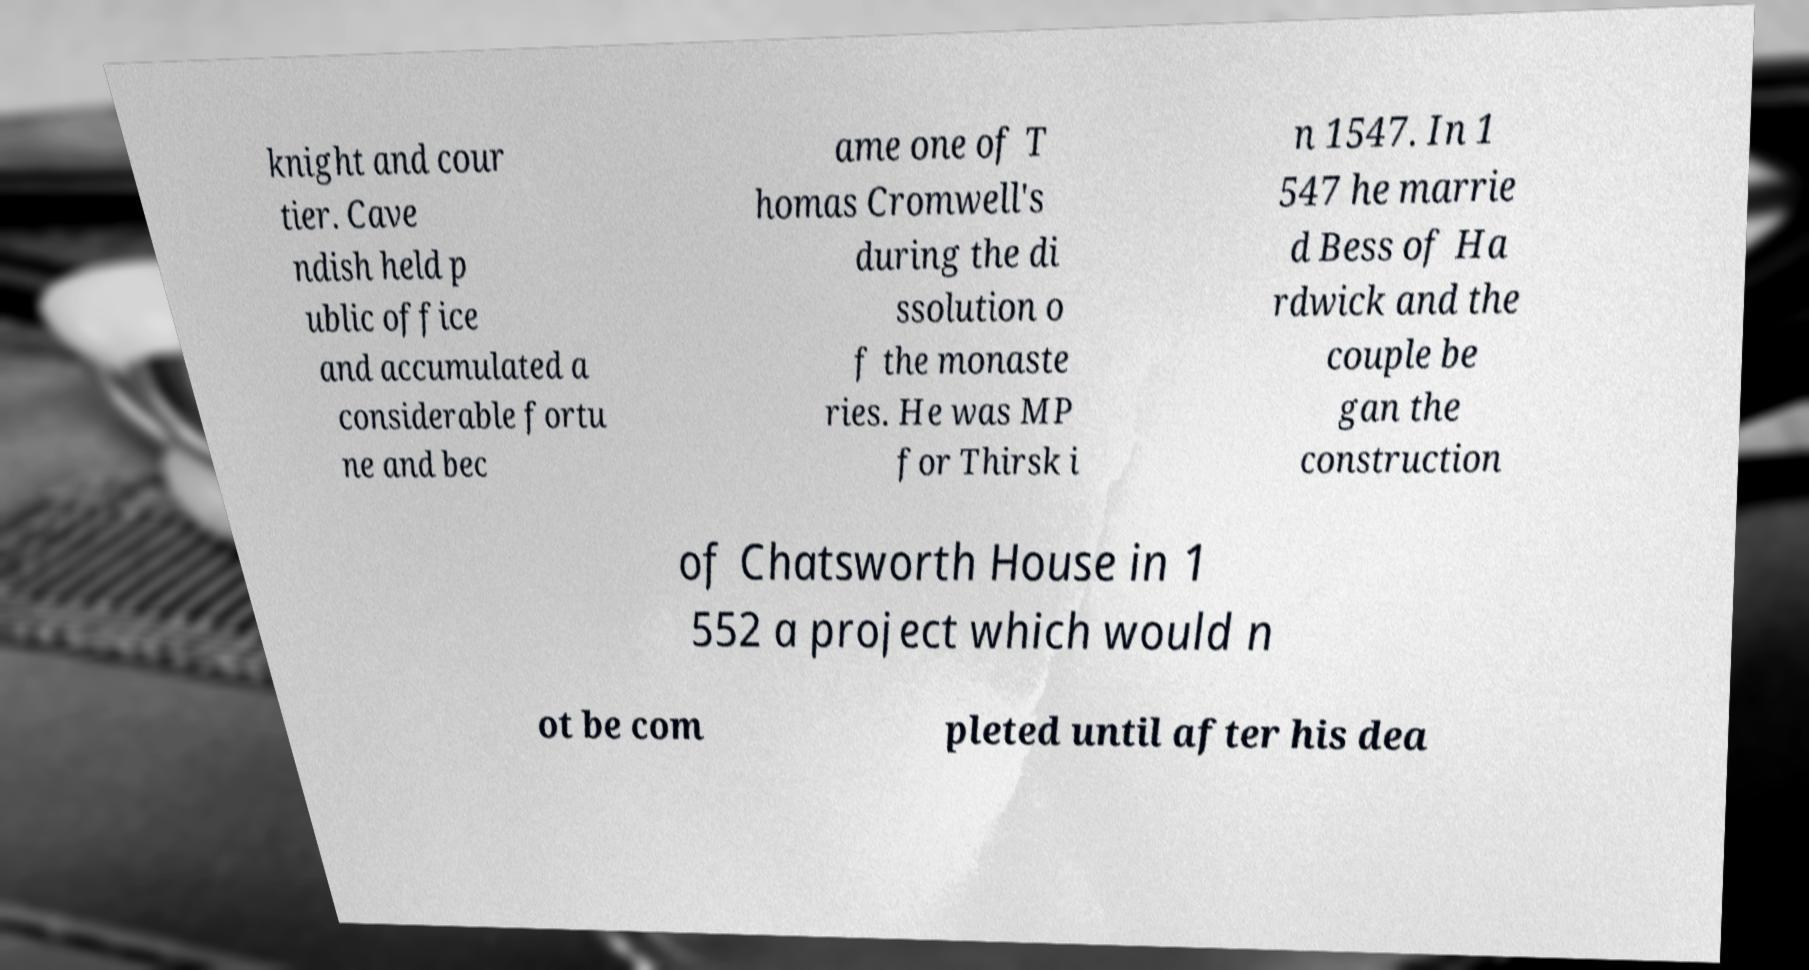For documentation purposes, I need the text within this image transcribed. Could you provide that? knight and cour tier. Cave ndish held p ublic office and accumulated a considerable fortu ne and bec ame one of T homas Cromwell's during the di ssolution o f the monaste ries. He was MP for Thirsk i n 1547. In 1 547 he marrie d Bess of Ha rdwick and the couple be gan the construction of Chatsworth House in 1 552 a project which would n ot be com pleted until after his dea 